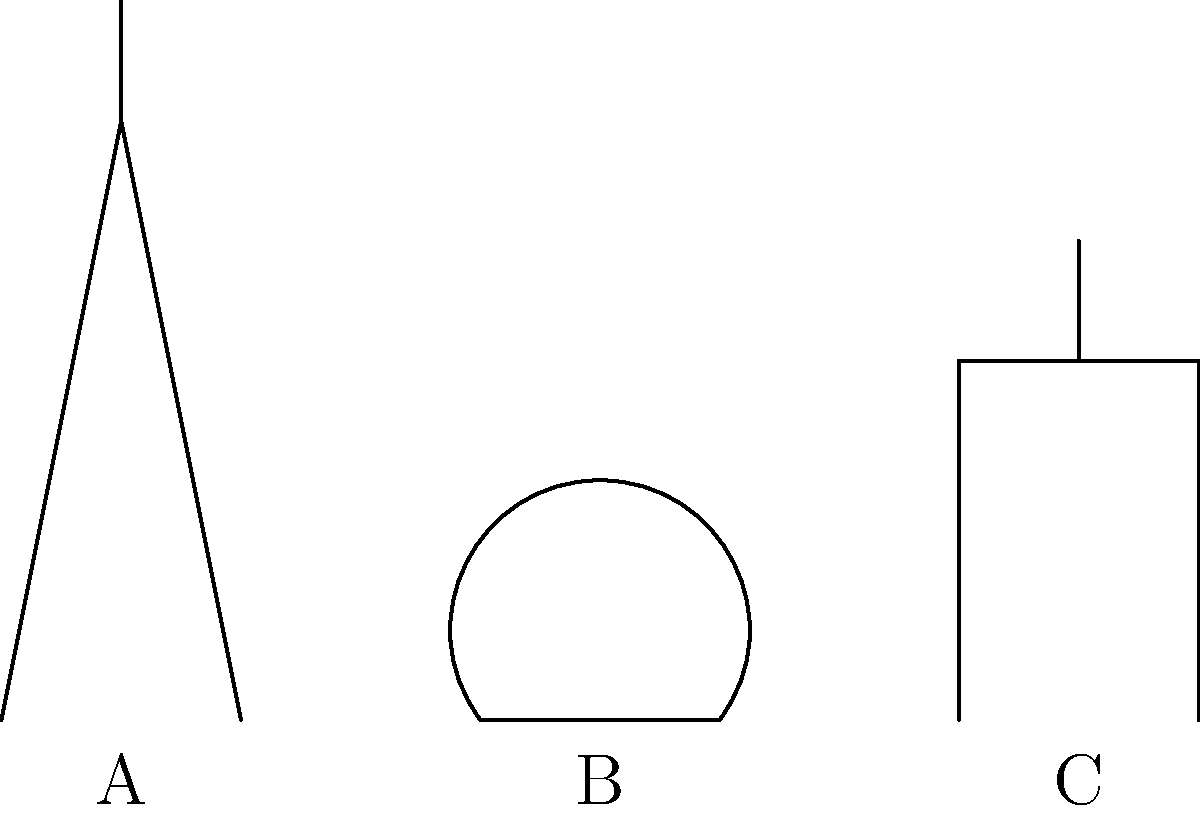Which of the simplified architectural sketches (A, B, or C) represents the iconic Parisian landmark known for its iron lattice structure and was built for the 1889 World's Fair? To answer this question, let's analyze each sketch:

1. Sketch A: This shows a tall, tapering structure with a narrow top. It has a distinctive triangular shape, which is characteristic of the Eiffel Tower. The Eiffel Tower is known for its iron lattice design and was indeed built for the 1889 World's Fair in Paris.

2. Sketch B: This depicts an arched structure with a flat base. This simplified representation is reminiscent of the Arc de Triomphe, another famous Parisian landmark. However, it was not built for the 1889 World's Fair and does not have an iron lattice structure.

3. Sketch C: This sketch shows a building with a rectangular base and a tall spire or tower in the center. This is likely a simplified representation of the Notre-Dame Cathedral. Like the Arc de Triomphe, it was not built for the 1889 World's Fair and does not feature an iron lattice structure.

Given the description in the question, which mentions an "iron lattice structure" and its construction for the "1889 World's Fair," the correct answer must be Sketch A, representing the Eiffel Tower.

The Eiffel Tower, designed by Gustave Eiffel and his team, was the centerpiece of the 1889 World's Fair in Paris. It stands 324 meters (1,063 feet) tall and is known for its distinctive iron lattice design, which gives it both strength and a relatively light weight for its size.
Answer: A 